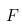<formula> <loc_0><loc_0><loc_500><loc_500>F</formula> 